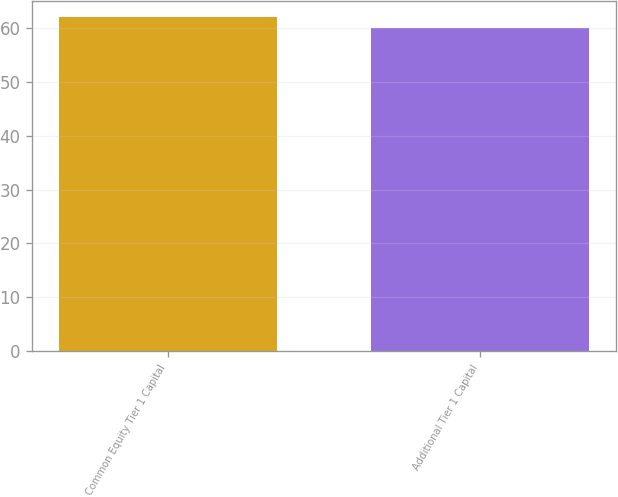<chart> <loc_0><loc_0><loc_500><loc_500><bar_chart><fcel>Common Equity Tier 1 Capital<fcel>Additional Tier 1 Capital<nl><fcel>62<fcel>60<nl></chart> 